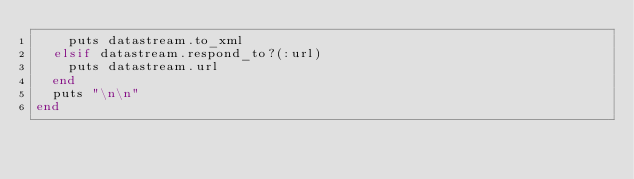Convert code to text. <code><loc_0><loc_0><loc_500><loc_500><_Ruby_>    puts datastream.to_xml
  elsif datastream.respond_to?(:url)
    puts datastream.url
  end
  puts "\n\n"
end
</code> 